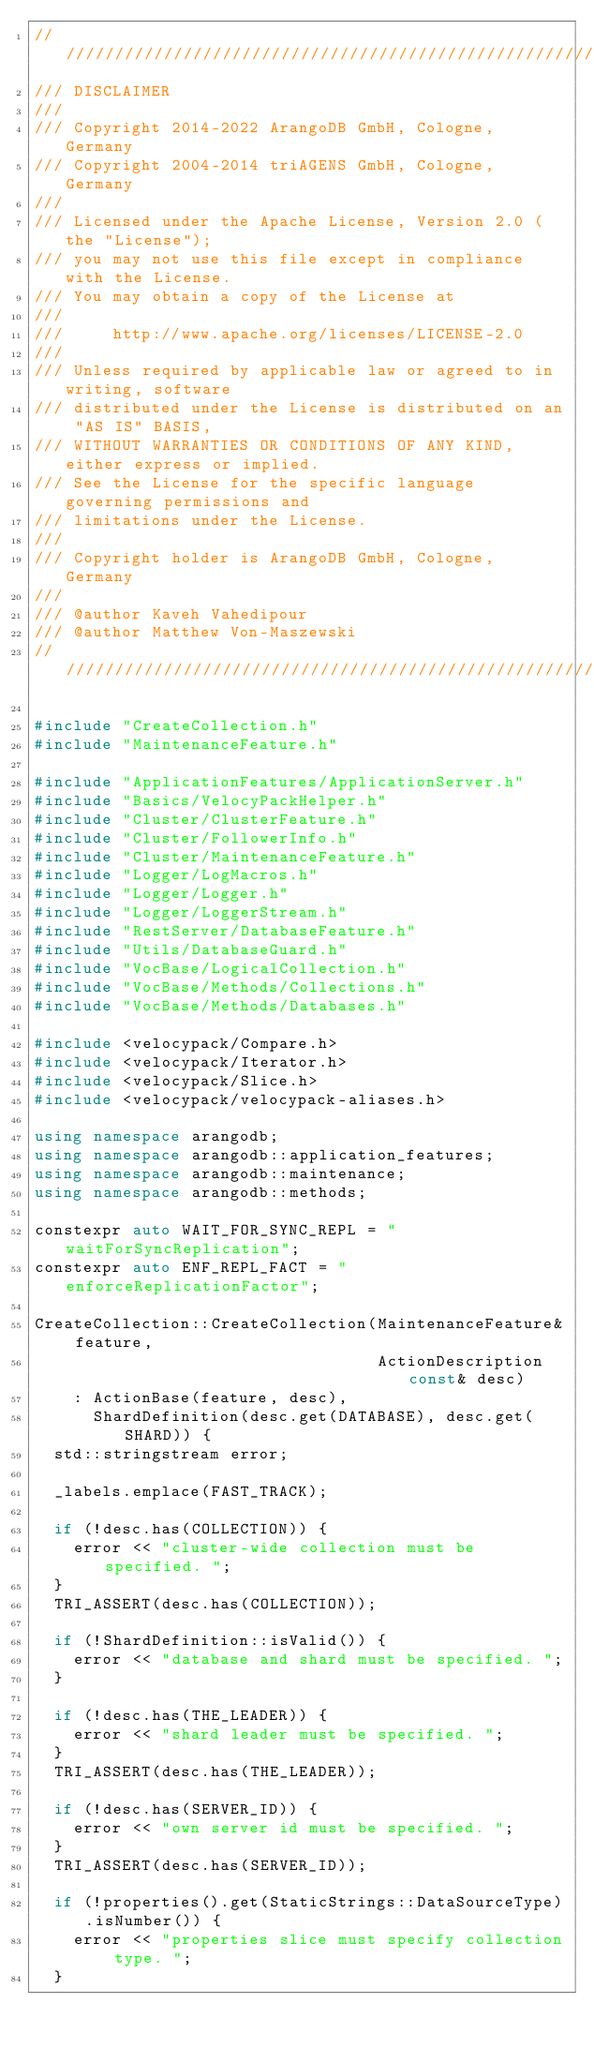Convert code to text. <code><loc_0><loc_0><loc_500><loc_500><_C++_>////////////////////////////////////////////////////////////////////////////////
/// DISCLAIMER
///
/// Copyright 2014-2022 ArangoDB GmbH, Cologne, Germany
/// Copyright 2004-2014 triAGENS GmbH, Cologne, Germany
///
/// Licensed under the Apache License, Version 2.0 (the "License");
/// you may not use this file except in compliance with the License.
/// You may obtain a copy of the License at
///
///     http://www.apache.org/licenses/LICENSE-2.0
///
/// Unless required by applicable law or agreed to in writing, software
/// distributed under the License is distributed on an "AS IS" BASIS,
/// WITHOUT WARRANTIES OR CONDITIONS OF ANY KIND, either express or implied.
/// See the License for the specific language governing permissions and
/// limitations under the License.
///
/// Copyright holder is ArangoDB GmbH, Cologne, Germany
///
/// @author Kaveh Vahedipour
/// @author Matthew Von-Maszewski
////////////////////////////////////////////////////////////////////////////////

#include "CreateCollection.h"
#include "MaintenanceFeature.h"

#include "ApplicationFeatures/ApplicationServer.h"
#include "Basics/VelocyPackHelper.h"
#include "Cluster/ClusterFeature.h"
#include "Cluster/FollowerInfo.h"
#include "Cluster/MaintenanceFeature.h"
#include "Logger/LogMacros.h"
#include "Logger/Logger.h"
#include "Logger/LoggerStream.h"
#include "RestServer/DatabaseFeature.h"
#include "Utils/DatabaseGuard.h"
#include "VocBase/LogicalCollection.h"
#include "VocBase/Methods/Collections.h"
#include "VocBase/Methods/Databases.h"

#include <velocypack/Compare.h>
#include <velocypack/Iterator.h>
#include <velocypack/Slice.h>
#include <velocypack/velocypack-aliases.h>

using namespace arangodb;
using namespace arangodb::application_features;
using namespace arangodb::maintenance;
using namespace arangodb::methods;

constexpr auto WAIT_FOR_SYNC_REPL = "waitForSyncReplication";
constexpr auto ENF_REPL_FACT = "enforceReplicationFactor";

CreateCollection::CreateCollection(MaintenanceFeature& feature,
                                   ActionDescription const& desc)
    : ActionBase(feature, desc),
      ShardDefinition(desc.get(DATABASE), desc.get(SHARD)) {
  std::stringstream error;

  _labels.emplace(FAST_TRACK);

  if (!desc.has(COLLECTION)) {
    error << "cluster-wide collection must be specified. ";
  }
  TRI_ASSERT(desc.has(COLLECTION));

  if (!ShardDefinition::isValid()) {
    error << "database and shard must be specified. ";
  }

  if (!desc.has(THE_LEADER)) {
    error << "shard leader must be specified. ";
  }
  TRI_ASSERT(desc.has(THE_LEADER));

  if (!desc.has(SERVER_ID)) {
    error << "own server id must be specified. ";
  }
  TRI_ASSERT(desc.has(SERVER_ID));

  if (!properties().get(StaticStrings::DataSourceType).isNumber()) {
    error << "properties slice must specify collection type. ";
  }</code> 